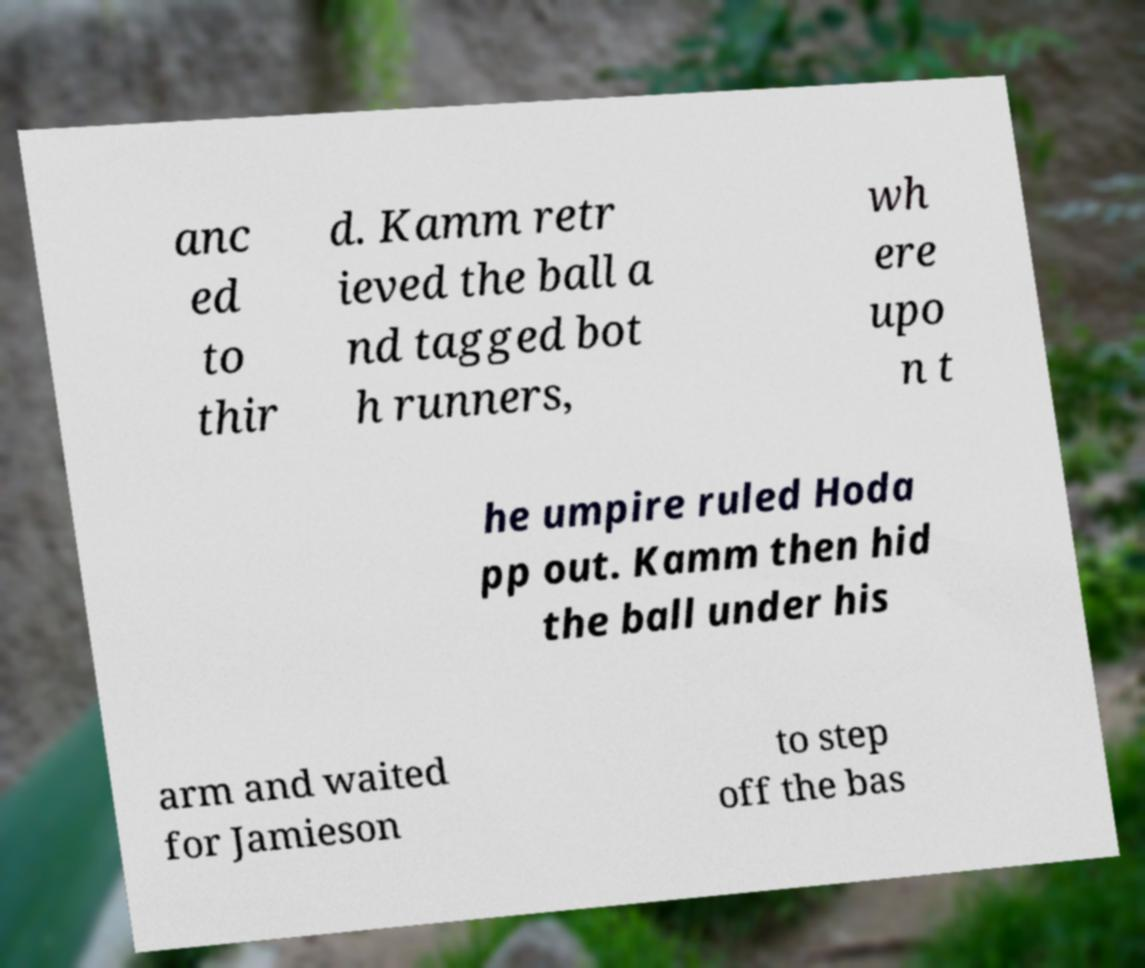Could you extract and type out the text from this image? anc ed to thir d. Kamm retr ieved the ball a nd tagged bot h runners, wh ere upo n t he umpire ruled Hoda pp out. Kamm then hid the ball under his arm and waited for Jamieson to step off the bas 